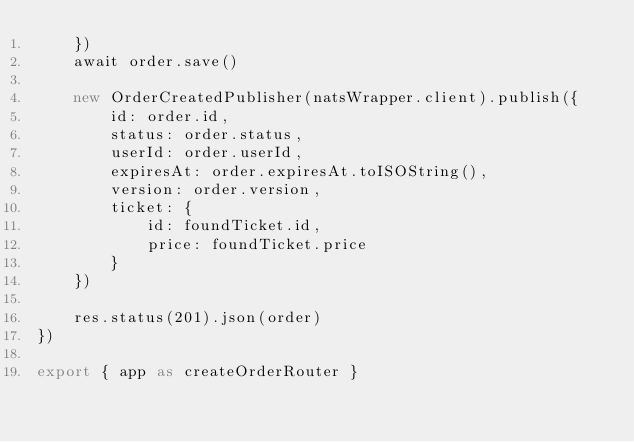<code> <loc_0><loc_0><loc_500><loc_500><_TypeScript_>	})
	await order.save()

	new OrderCreatedPublisher(natsWrapper.client).publish({
		id: order.id,
		status: order.status,
		userId: order.userId,
		expiresAt: order.expiresAt.toISOString(),
		version: order.version,
		ticket: {
			id: foundTicket.id,
			price: foundTicket.price
		}
	})

	res.status(201).json(order)
})

export { app as createOrderRouter }
</code> 